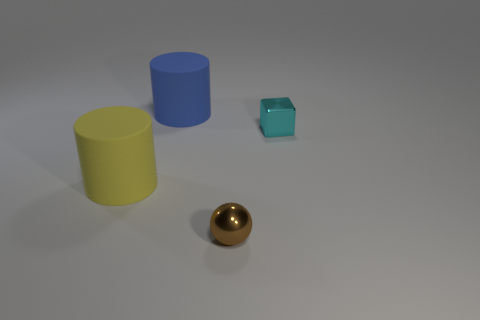Add 3 blue rubber cylinders. How many objects exist? 7 Subtract all balls. How many objects are left? 3 Subtract 0 green cylinders. How many objects are left? 4 Subtract all cubes. Subtract all big blue metal objects. How many objects are left? 3 Add 3 blue matte cylinders. How many blue matte cylinders are left? 4 Add 1 tiny cyan metallic things. How many tiny cyan metallic things exist? 2 